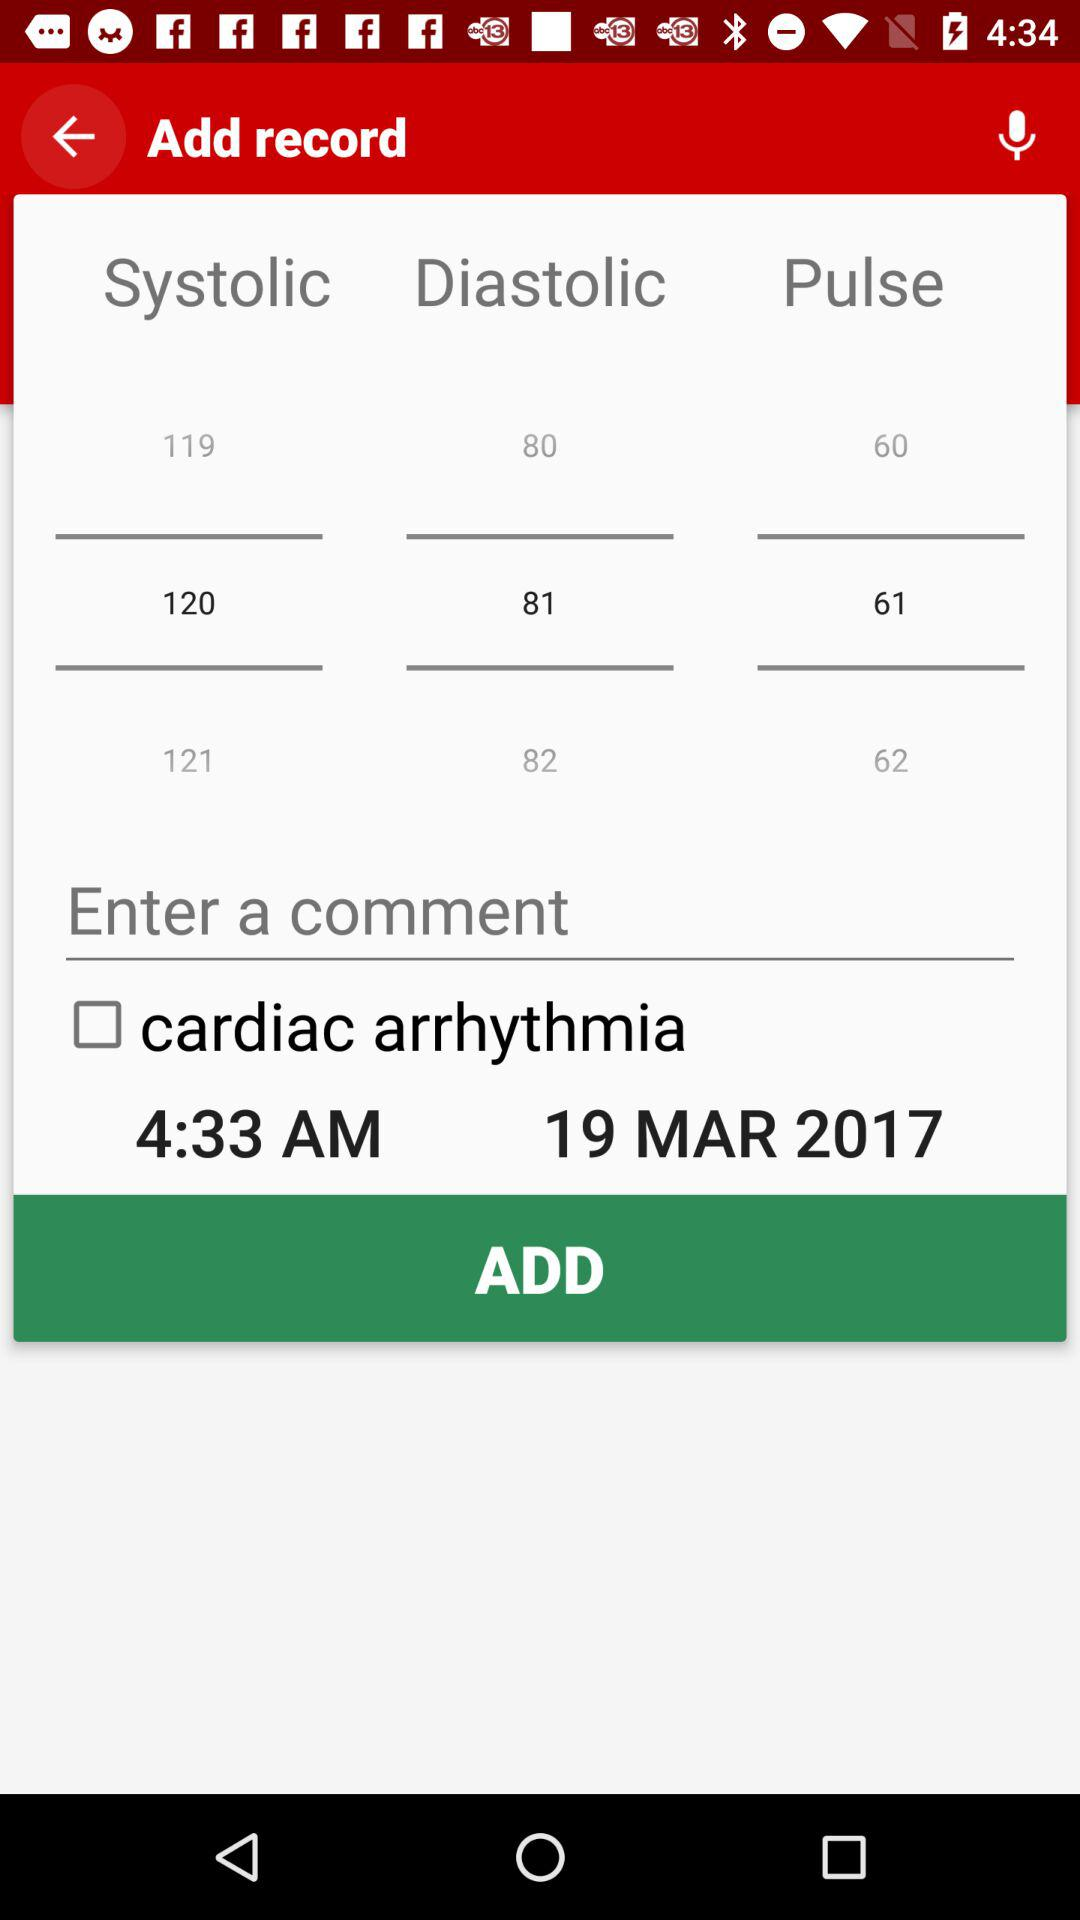What is the selected systolic value? The selected systolic value is 120. 